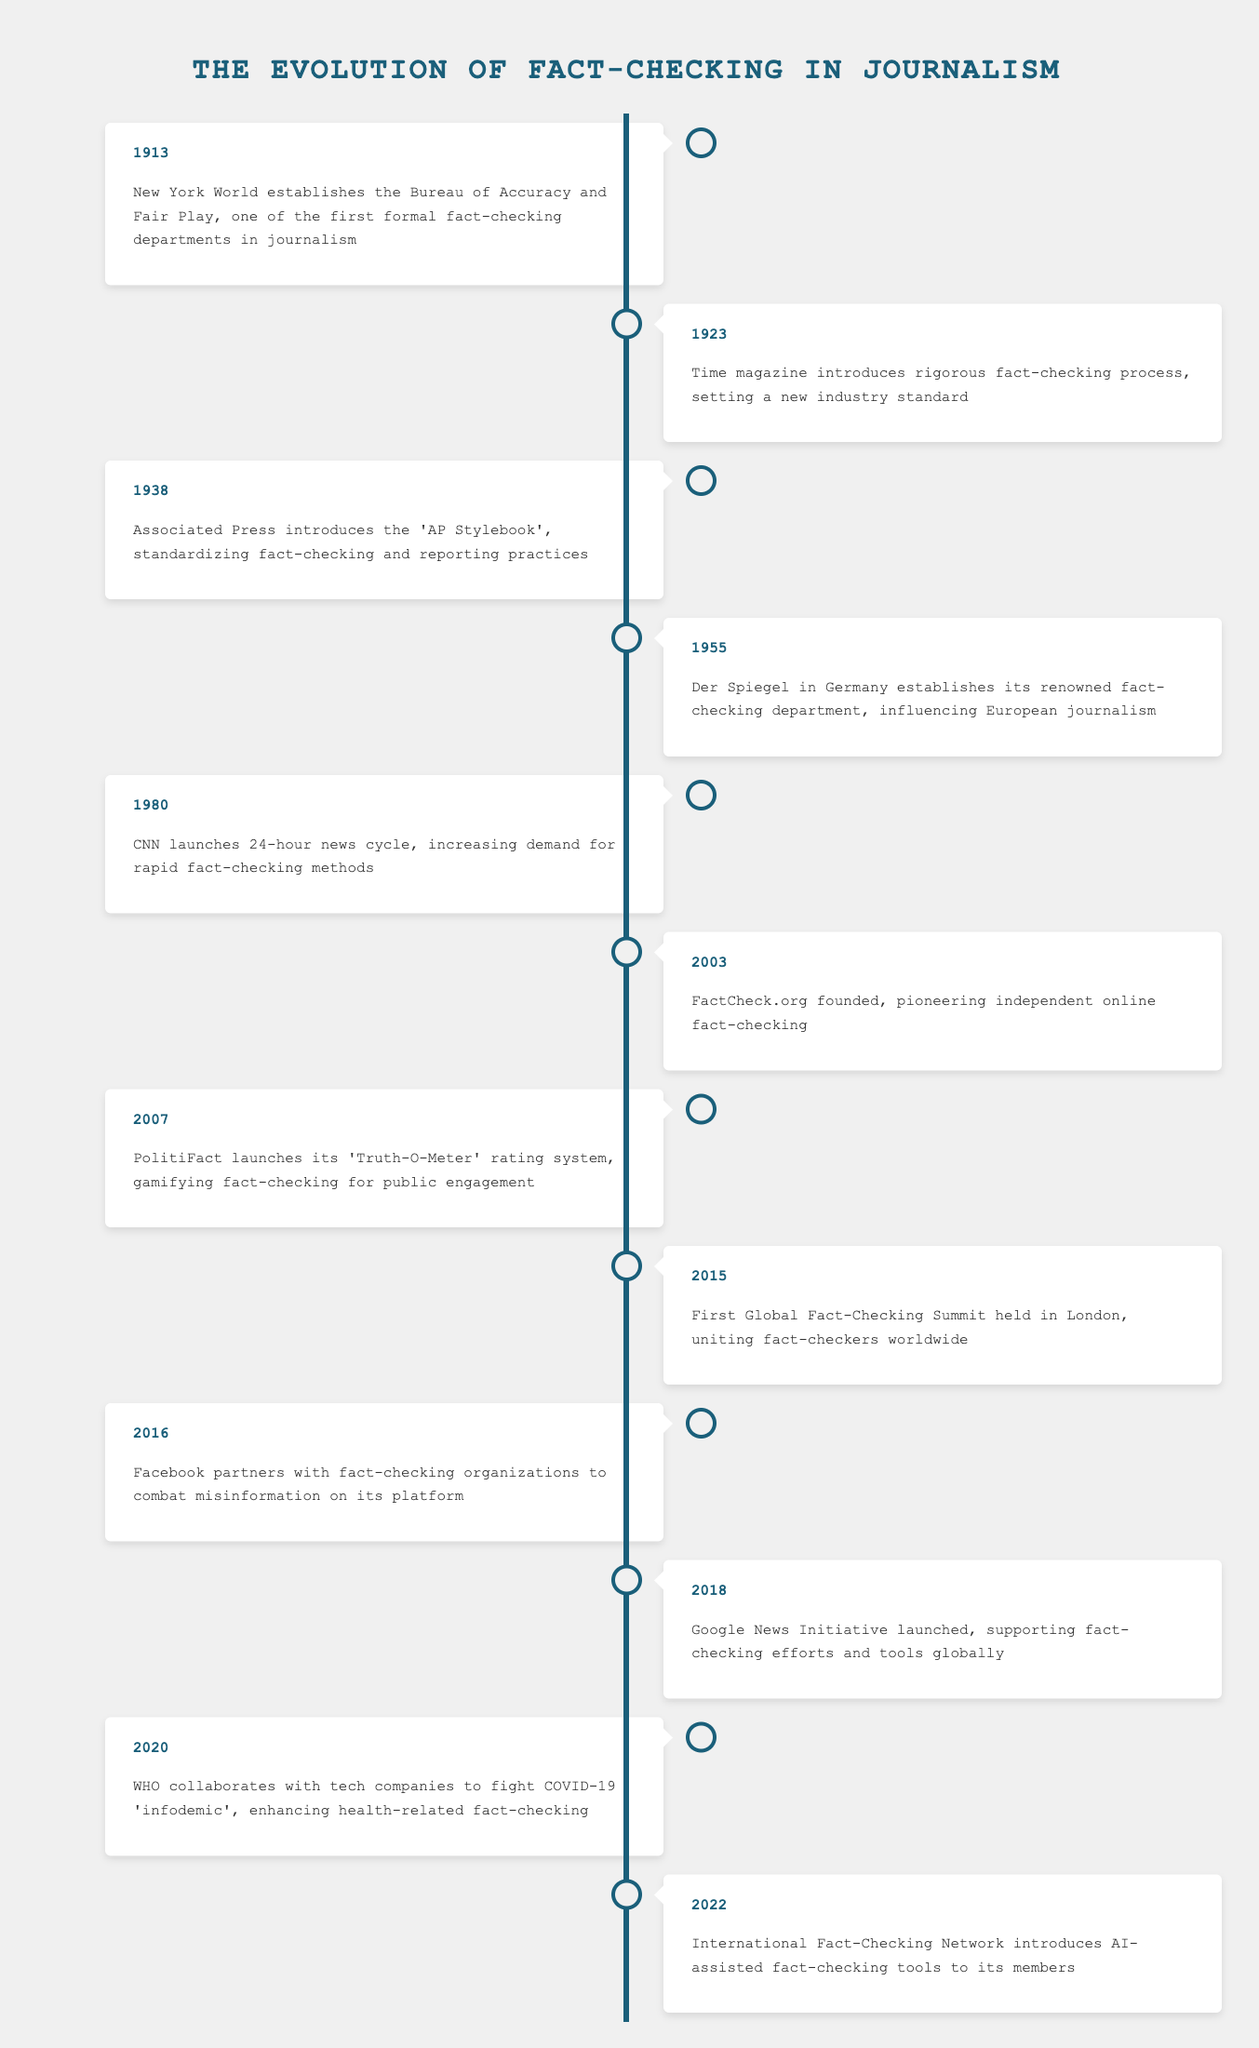What year did Time magazine introduce its rigorous fact-checking process? The table shows that the event occurred in 1923.
Answer: 1923 What was established by the New York World in 1913? The table indicates that the New York World established the Bureau of Accuracy and Fair Play in 1913.
Answer: Bureau of Accuracy and Fair Play Which organization's fact-checking method was launched in 2007? According to the table, PolitiFact launched its 'Truth-O-Meter' rating system in 2007.
Answer: PolitiFact How many years apart were the establishment of the Bureau of Accuracy and Fair Play and the launch of CNN's 24-hour news cycle? The Bureau of Accuracy and Fair Play was established in 1913 and CNN's 24-hour news cycle launched in 1980. The difference is 1980 - 1913 = 67 years.
Answer: 67 years Did the Associated Press contribute to standardizing fact-checking practices? The table confirms that the Associated Press introduced the 'AP Stylebook' in 1938, which helped standardize fact-checking practices.
Answer: Yes What was the focus of the collaboration between WHO and tech companies in 2020? The collaboration aimed to fight the COVID-19 'infodemic', as mentioned in the 2020 entry in the table.
Answer: COVID-19 'infodemic' What is the earliest event listed in the timeline? The earliest event is from 1913 when the New York World established the Bureau of Accuracy and Fair Play.
Answer: 1913 In which year was the Google News Initiative launched? According to the timeline, the Google News Initiative was launched in 2018.
Answer: 2018 If you sum the years of all the events listed, what is the total? The years listed are 1913, 1923, 1938, 1955, 1980, 2003, 2007, 2015, 2016, 2018, 2020, and 2022. Summing these gives: 1913 + 1923 + 1938 + 1955 + 1980 + 2003 + 2007 + 2015 + 2016 + 2018 + 2020 + 2022 = 23610.
Answer: 23610 